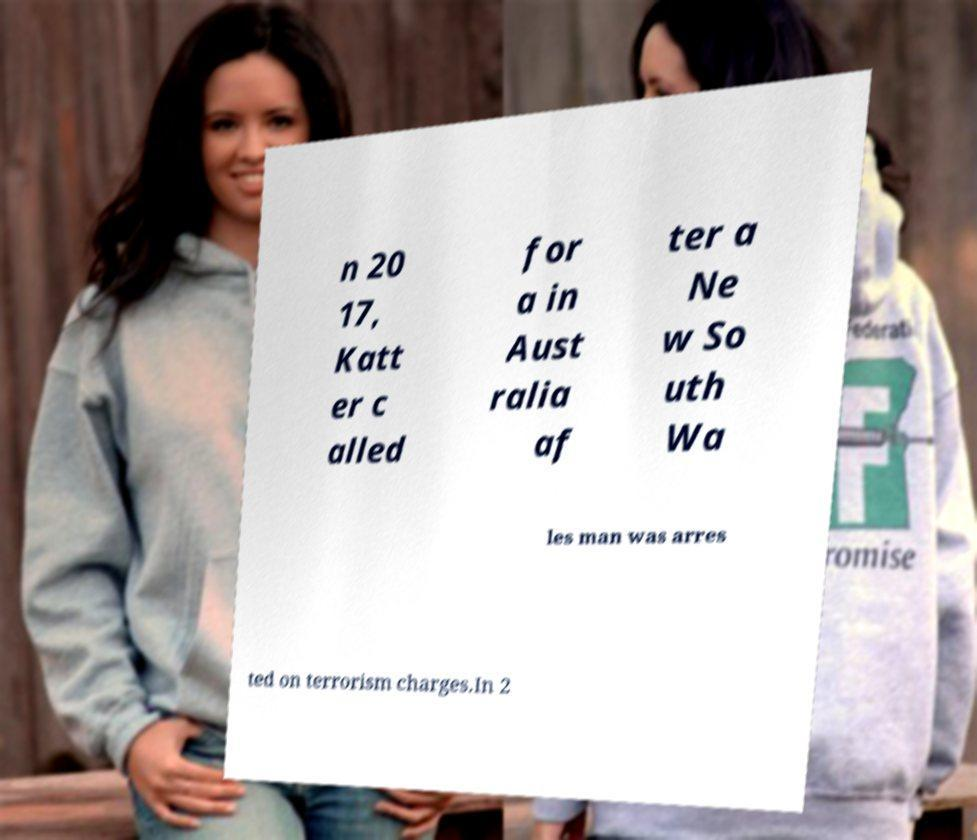Can you accurately transcribe the text from the provided image for me? n 20 17, Katt er c alled for a in Aust ralia af ter a Ne w So uth Wa les man was arres ted on terrorism charges.In 2 